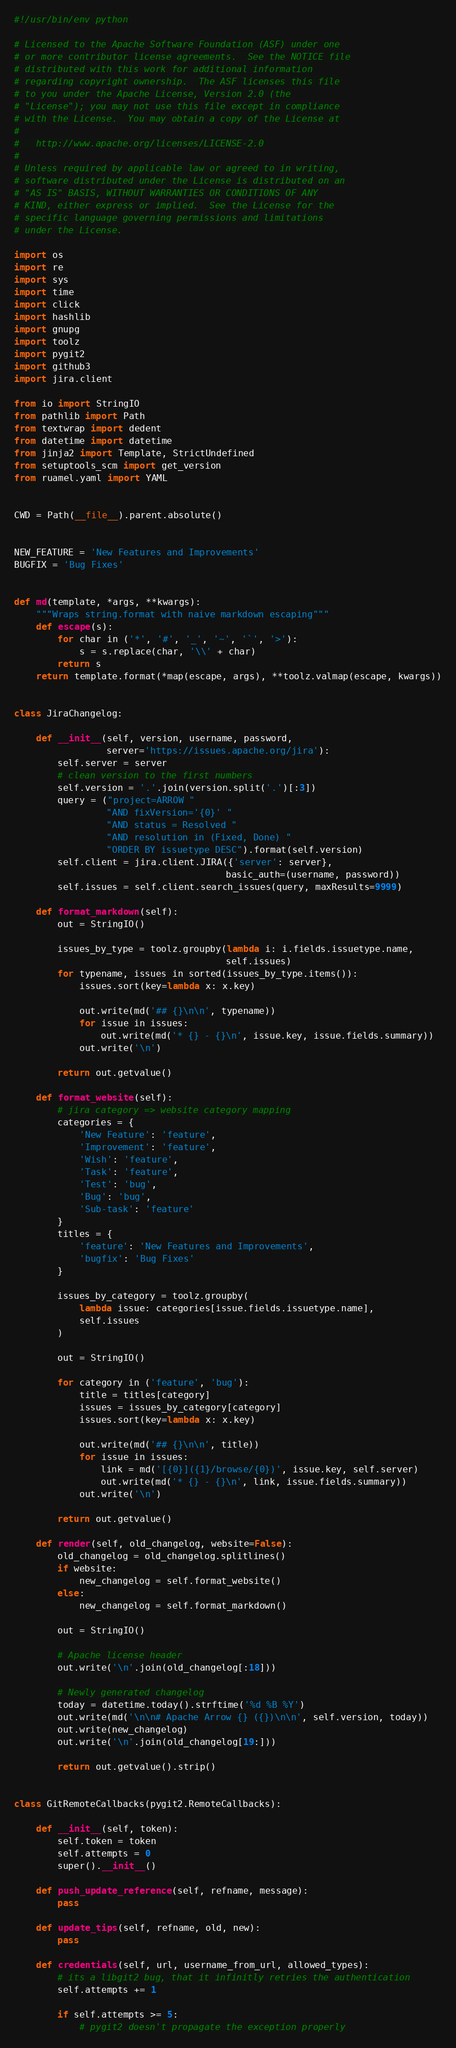Convert code to text. <code><loc_0><loc_0><loc_500><loc_500><_Python_>#!/usr/bin/env python

# Licensed to the Apache Software Foundation (ASF) under one
# or more contributor license agreements.  See the NOTICE file
# distributed with this work for additional information
# regarding copyright ownership.  The ASF licenses this file
# to you under the Apache License, Version 2.0 (the
# "License"); you may not use this file except in compliance
# with the License.  You may obtain a copy of the License at
#
#   http://www.apache.org/licenses/LICENSE-2.0
#
# Unless required by applicable law or agreed to in writing,
# software distributed under the License is distributed on an
# "AS IS" BASIS, WITHOUT WARRANTIES OR CONDITIONS OF ANY
# KIND, either express or implied.  See the License for the
# specific language governing permissions and limitations
# under the License.

import os
import re
import sys
import time
import click
import hashlib
import gnupg
import toolz
import pygit2
import github3
import jira.client

from io import StringIO
from pathlib import Path
from textwrap import dedent
from datetime import datetime
from jinja2 import Template, StrictUndefined
from setuptools_scm import get_version
from ruamel.yaml import YAML


CWD = Path(__file__).parent.absolute()


NEW_FEATURE = 'New Features and Improvements'
BUGFIX = 'Bug Fixes'


def md(template, *args, **kwargs):
    """Wraps string.format with naive markdown escaping"""
    def escape(s):
        for char in ('*', '#', '_', '~', '`', '>'):
            s = s.replace(char, '\\' + char)
        return s
    return template.format(*map(escape, args), **toolz.valmap(escape, kwargs))


class JiraChangelog:

    def __init__(self, version, username, password,
                 server='https://issues.apache.org/jira'):
        self.server = server
        # clean version to the first numbers
        self.version = '.'.join(version.split('.')[:3])
        query = ("project=ARROW "
                 "AND fixVersion='{0}' "
                 "AND status = Resolved "
                 "AND resolution in (Fixed, Done) "
                 "ORDER BY issuetype DESC").format(self.version)
        self.client = jira.client.JIRA({'server': server},
                                       basic_auth=(username, password))
        self.issues = self.client.search_issues(query, maxResults=9999)

    def format_markdown(self):
        out = StringIO()

        issues_by_type = toolz.groupby(lambda i: i.fields.issuetype.name,
                                       self.issues)
        for typename, issues in sorted(issues_by_type.items()):
            issues.sort(key=lambda x: x.key)

            out.write(md('## {}\n\n', typename))
            for issue in issues:
                out.write(md('* {} - {}\n', issue.key, issue.fields.summary))
            out.write('\n')

        return out.getvalue()

    def format_website(self):
        # jira category => website category mapping
        categories = {
            'New Feature': 'feature',
            'Improvement': 'feature',
            'Wish': 'feature',
            'Task': 'feature',
            'Test': 'bug',
            'Bug': 'bug',
            'Sub-task': 'feature'
        }
        titles = {
            'feature': 'New Features and Improvements',
            'bugfix': 'Bug Fixes'
        }

        issues_by_category = toolz.groupby(
            lambda issue: categories[issue.fields.issuetype.name],
            self.issues
        )

        out = StringIO()

        for category in ('feature', 'bug'):
            title = titles[category]
            issues = issues_by_category[category]
            issues.sort(key=lambda x: x.key)

            out.write(md('## {}\n\n', title))
            for issue in issues:
                link = md('[{0}]({1}/browse/{0})', issue.key, self.server)
                out.write(md('* {} - {}\n', link, issue.fields.summary))
            out.write('\n')

        return out.getvalue()

    def render(self, old_changelog, website=False):
        old_changelog = old_changelog.splitlines()
        if website:
            new_changelog = self.format_website()
        else:
            new_changelog = self.format_markdown()

        out = StringIO()

        # Apache license header
        out.write('\n'.join(old_changelog[:18]))

        # Newly generated changelog
        today = datetime.today().strftime('%d %B %Y')
        out.write(md('\n\n# Apache Arrow {} ({})\n\n', self.version, today))
        out.write(new_changelog)
        out.write('\n'.join(old_changelog[19:]))

        return out.getvalue().strip()


class GitRemoteCallbacks(pygit2.RemoteCallbacks):

    def __init__(self, token):
        self.token = token
        self.attempts = 0
        super().__init__()

    def push_update_reference(self, refname, message):
        pass

    def update_tips(self, refname, old, new):
        pass

    def credentials(self, url, username_from_url, allowed_types):
        # its a libgit2 bug, that it infinitly retries the authentication
        self.attempts += 1

        if self.attempts >= 5:
            # pygit2 doesn't propagate the exception properly</code> 